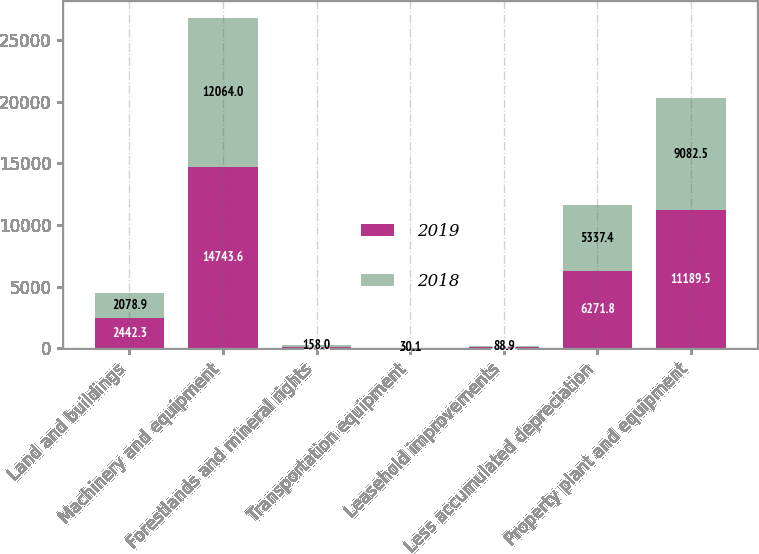Convert chart to OTSL. <chart><loc_0><loc_0><loc_500><loc_500><stacked_bar_chart><ecel><fcel>Land and buildings<fcel>Machinery and equipment<fcel>Forestlands and mineral rights<fcel>Transportation equipment<fcel>Leasehold improvements<fcel>Less accumulated depreciation<fcel>Property plant and equipment<nl><fcel>2019<fcel>2442.3<fcel>14743.6<fcel>144<fcel>31.2<fcel>100.2<fcel>6271.8<fcel>11189.5<nl><fcel>2018<fcel>2078.9<fcel>12064<fcel>158<fcel>30.1<fcel>88.9<fcel>5337.4<fcel>9082.5<nl></chart> 